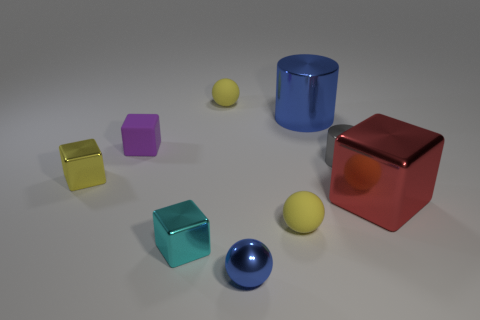Subtract all blocks. How many objects are left? 5 Subtract all cylinders. Subtract all blue objects. How many objects are left? 5 Add 1 yellow matte objects. How many yellow matte objects are left? 3 Add 4 tiny purple matte things. How many tiny purple matte things exist? 5 Subtract 1 red cubes. How many objects are left? 8 